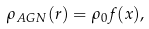Convert formula to latex. <formula><loc_0><loc_0><loc_500><loc_500>\rho _ { A G N } ( r ) = \rho _ { 0 } f ( x ) ,</formula> 